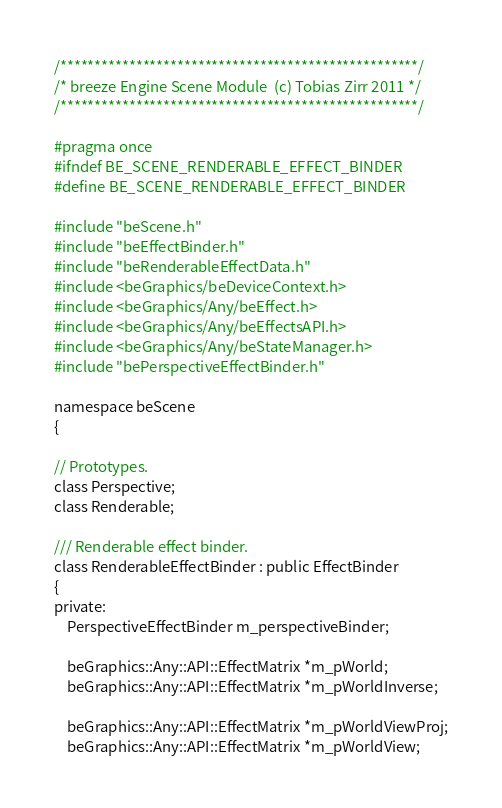Convert code to text. <code><loc_0><loc_0><loc_500><loc_500><_C_>/****************************************************/
/* breeze Engine Scene Module  (c) Tobias Zirr 2011 */
/****************************************************/

#pragma once
#ifndef BE_SCENE_RENDERABLE_EFFECT_BINDER
#define BE_SCENE_RENDERABLE_EFFECT_BINDER

#include "beScene.h"
#include "beEffectBinder.h"
#include "beRenderableEffectData.h"
#include <beGraphics/beDeviceContext.h>
#include <beGraphics/Any/beEffect.h>
#include <beGraphics/Any/beEffectsAPI.h>
#include <beGraphics/Any/beStateManager.h>
#include "bePerspectiveEffectBinder.h"

namespace beScene
{

// Prototypes.
class Perspective;
class Renderable;

/// Renderable effect binder.
class RenderableEffectBinder : public EffectBinder
{
private:
	PerspectiveEffectBinder m_perspectiveBinder;

	beGraphics::Any::API::EffectMatrix *m_pWorld;
	beGraphics::Any::API::EffectMatrix *m_pWorldInverse;

	beGraphics::Any::API::EffectMatrix *m_pWorldViewProj;
	beGraphics::Any::API::EffectMatrix *m_pWorldView;
</code> 